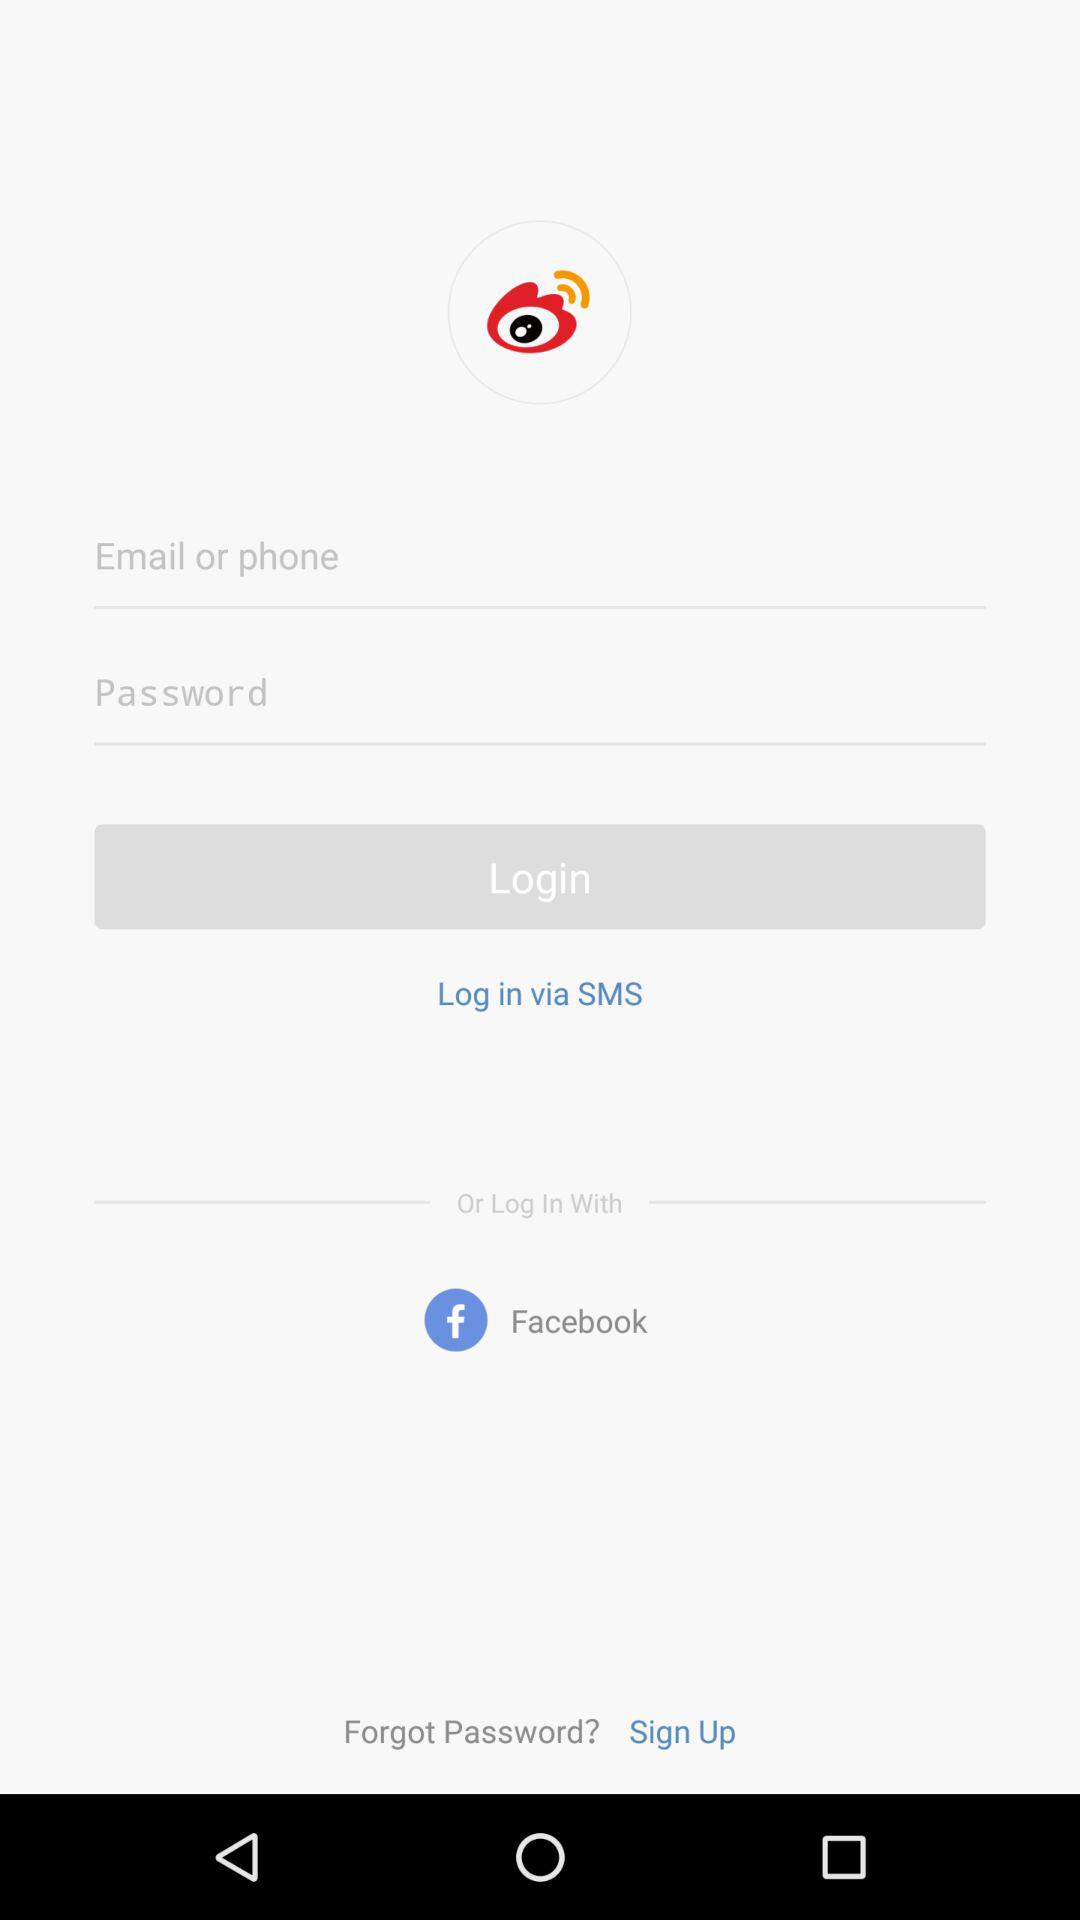What applications can be used to log in to a profile? The application "Facebook" can be used to log in to a profile. 